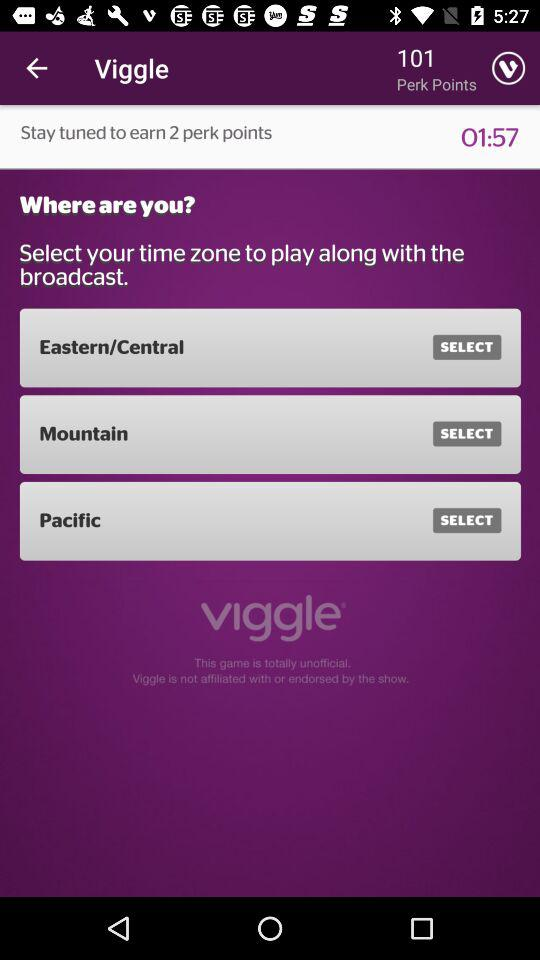How many perk points will I earn if I stay tuned?
Answer the question using a single word or phrase. 2 